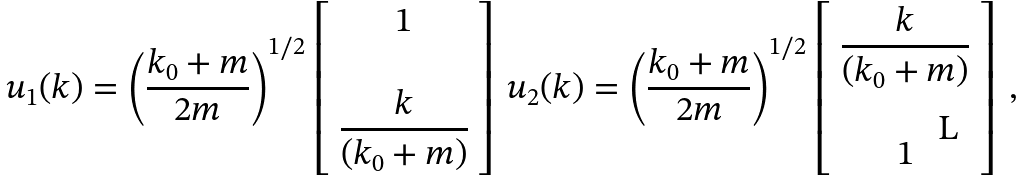Convert formula to latex. <formula><loc_0><loc_0><loc_500><loc_500>u _ { 1 } ( { k } ) = \left ( \frac { k _ { 0 } + m } { 2 m } \right ) ^ { 1 / 2 } \left [ \begin{array} { c } 1 \\ \\ { k } \\ \overline { ( k _ { 0 } + m ) } \\ \end{array} \right ] \, u _ { 2 } ( { k } ) = \left ( \frac { k _ { 0 } + m } { 2 m } \right ) ^ { 1 / 2 } \left [ \begin{array} { c } { k } \\ \overline { ( k _ { 0 } + m ) } \\ \\ 1 \end{array} \right ] \, ,</formula> 